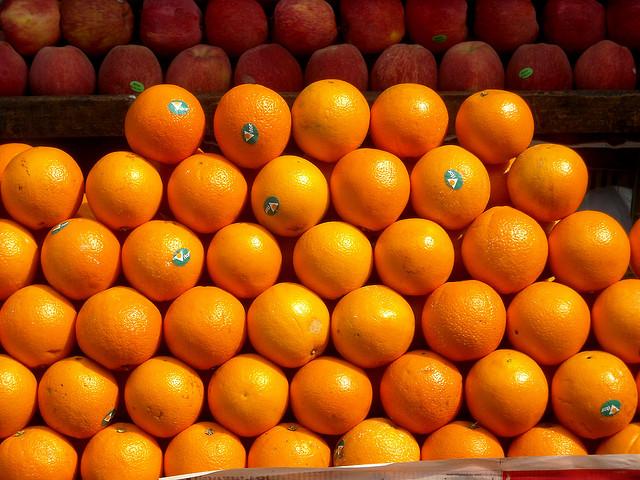How many oranges are touching the right side of the picture frame?
Short answer required. 4. If you pulled an orange from the middle would the other oranges fall?
Short answer required. Yes. What shape do these oranges form?
Concise answer only. Circle. Are there stickers?
Answer briefly. Yes. 